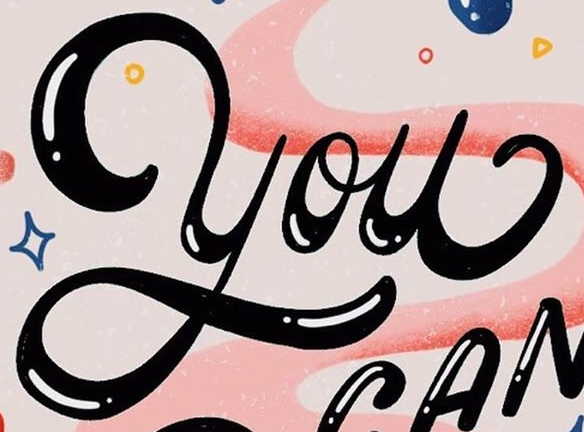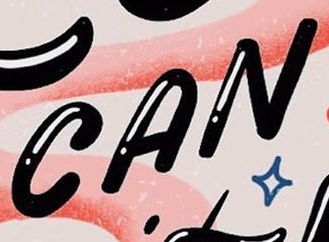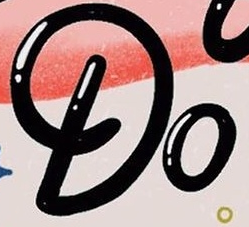What words are shown in these images in order, separated by a semicolon? You; CAN; Do 